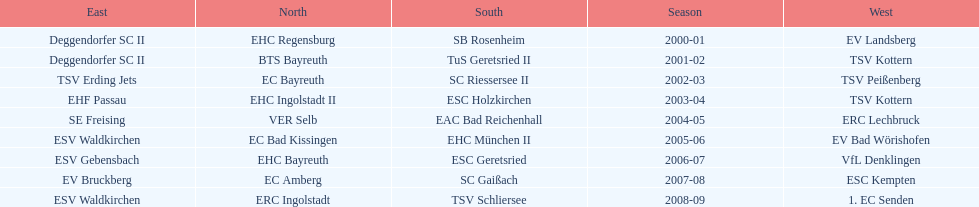Which name appears more often, kottern or bayreuth? Bayreuth. 